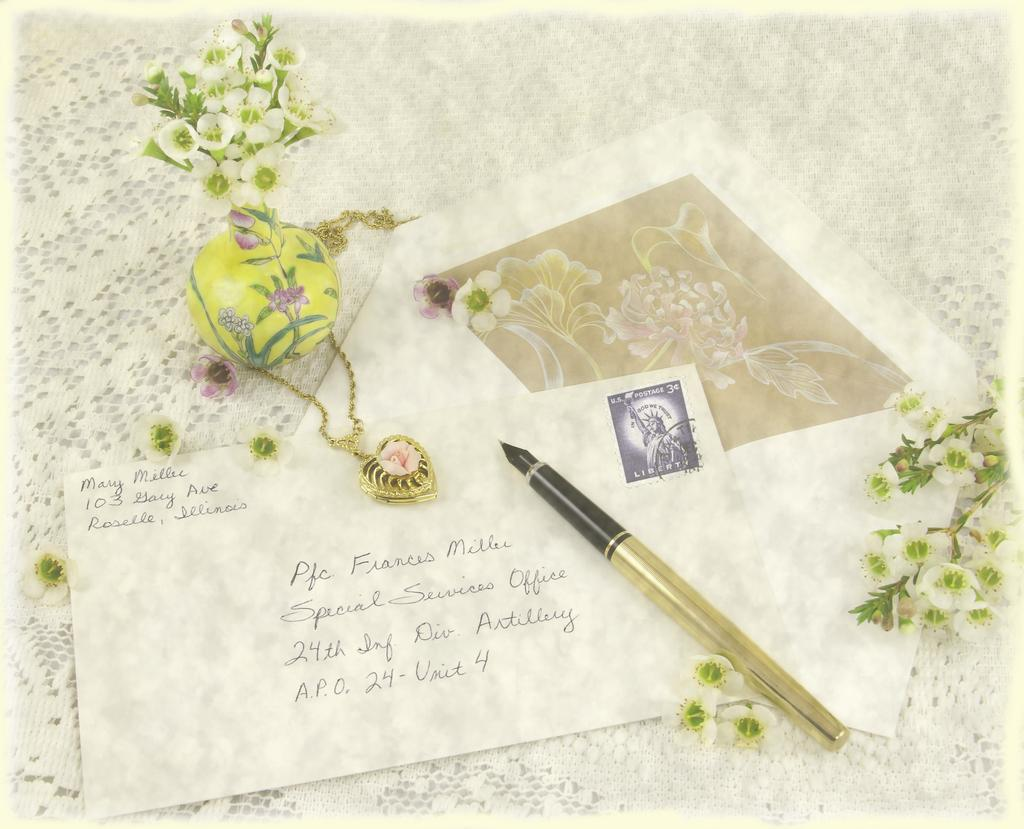<image>
Create a compact narrative representing the image presented. A stamped envelope that was sent from Illinois sits on a table. 